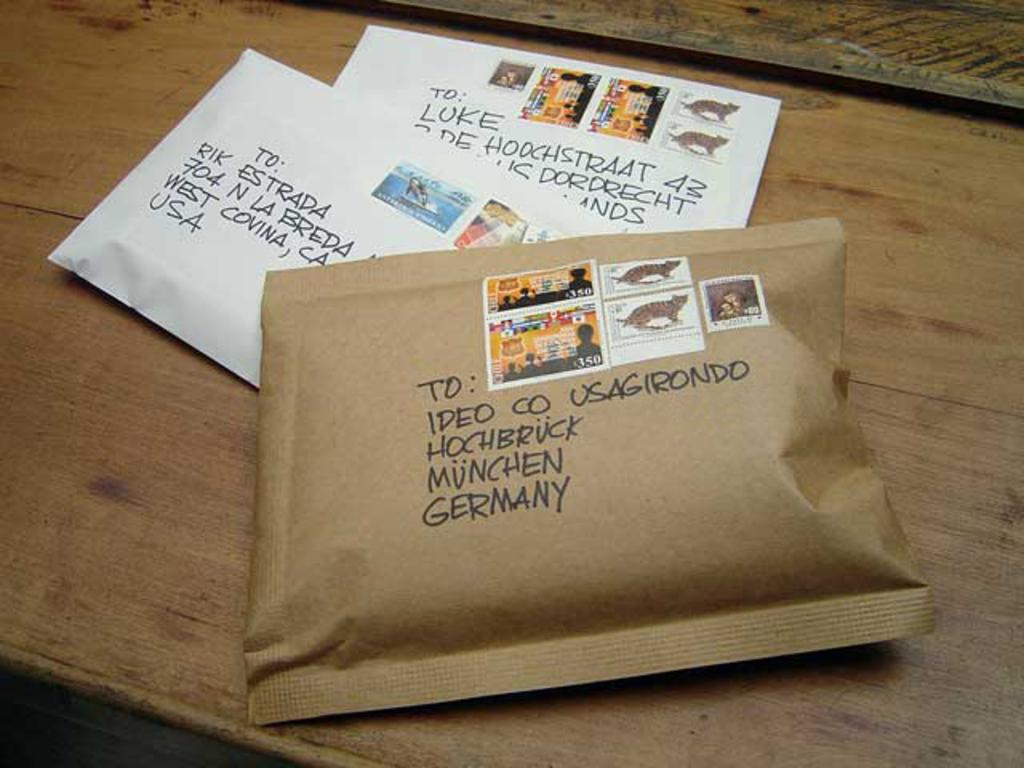<image>
Relay a brief, clear account of the picture shown. Two letters and one package addressed to Ideo Co Usa Girondo Hochbruck Munchen, Germany. 